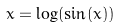Convert formula to latex. <formula><loc_0><loc_0><loc_500><loc_500>x = \log ( \sin ( x ) )</formula> 